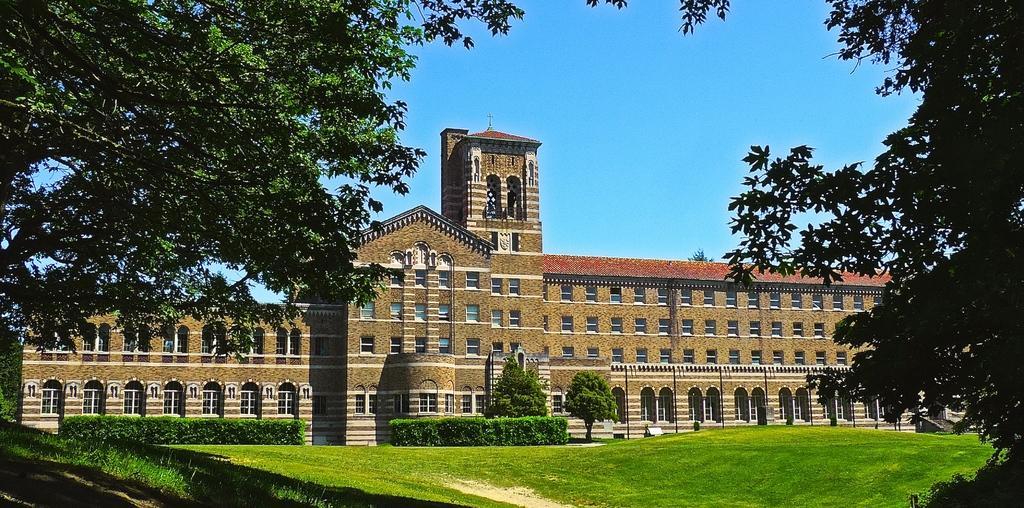How would you summarize this image in a sentence or two? In this image, we can see trees, buildings, hedges and at the bottom, there is ground. 